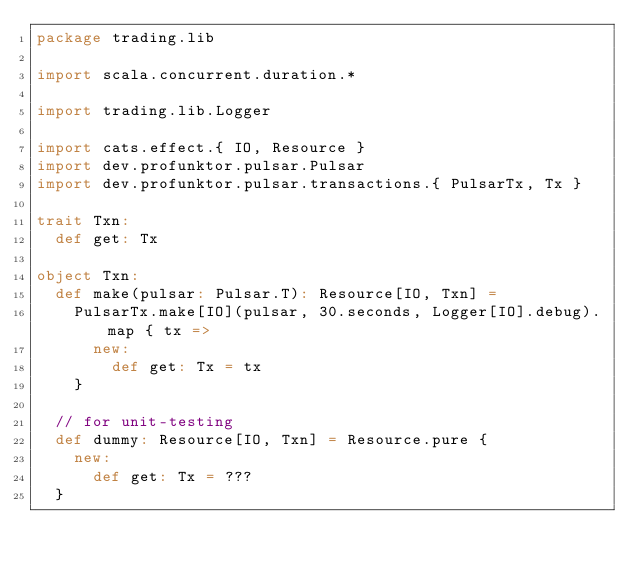Convert code to text. <code><loc_0><loc_0><loc_500><loc_500><_Scala_>package trading.lib

import scala.concurrent.duration.*

import trading.lib.Logger

import cats.effect.{ IO, Resource }
import dev.profunktor.pulsar.Pulsar
import dev.profunktor.pulsar.transactions.{ PulsarTx, Tx }

trait Txn:
  def get: Tx

object Txn:
  def make(pulsar: Pulsar.T): Resource[IO, Txn] =
    PulsarTx.make[IO](pulsar, 30.seconds, Logger[IO].debug).map { tx =>
      new:
        def get: Tx = tx
    }

  // for unit-testing
  def dummy: Resource[IO, Txn] = Resource.pure {
    new:
      def get: Tx = ???
  }
</code> 